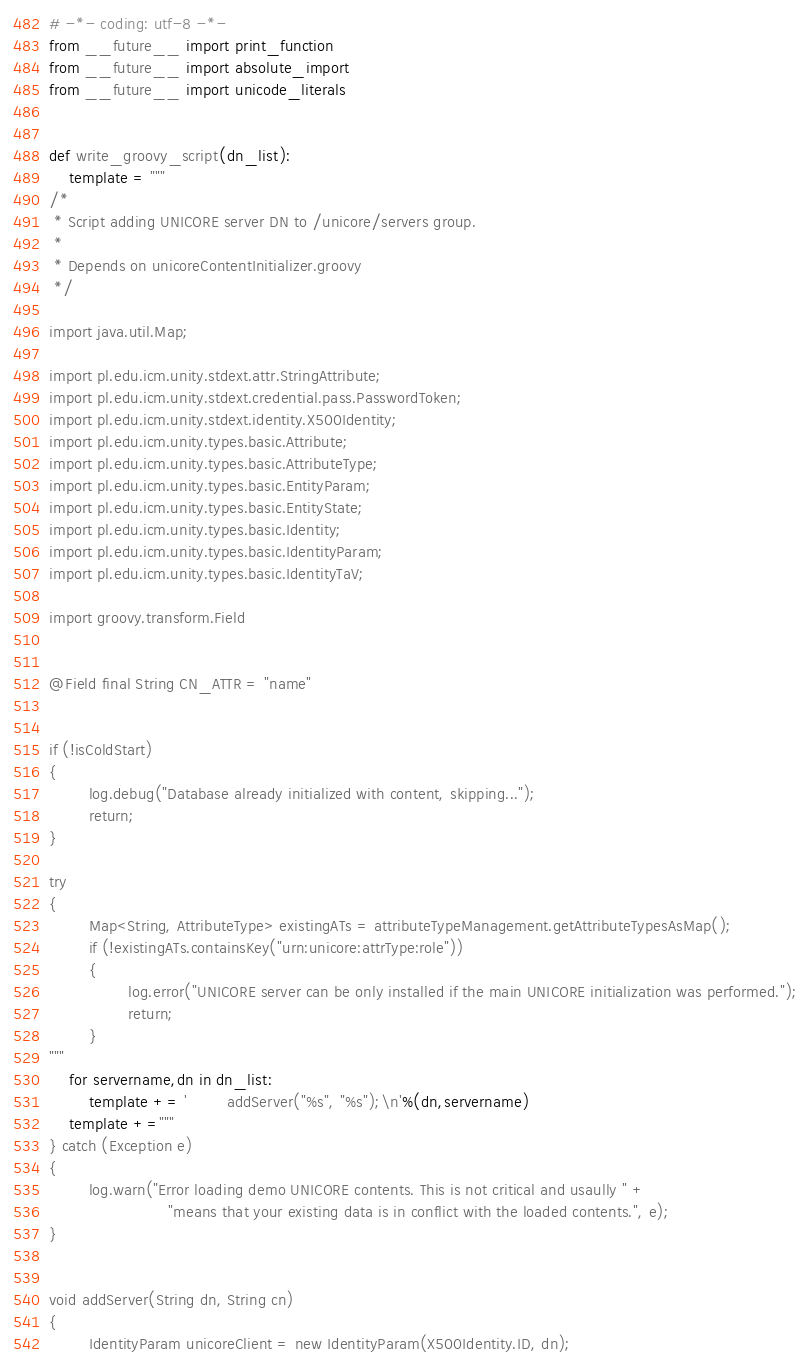Convert code to text. <code><loc_0><loc_0><loc_500><loc_500><_Python_># -*- coding: utf-8 -*-
from __future__ import print_function
from __future__ import absolute_import
from __future__ import unicode_literals


def write_groovy_script(dn_list):
    template = """
/*
 * Script adding UNICORE server DN to /unicore/servers group.  
 *
 * Depends on unicoreContentInitializer.groovy
 */

import java.util.Map;

import pl.edu.icm.unity.stdext.attr.StringAttribute;
import pl.edu.icm.unity.stdext.credential.pass.PasswordToken;
import pl.edu.icm.unity.stdext.identity.X500Identity;
import pl.edu.icm.unity.types.basic.Attribute;
import pl.edu.icm.unity.types.basic.AttributeType;
import pl.edu.icm.unity.types.basic.EntityParam;
import pl.edu.icm.unity.types.basic.EntityState;
import pl.edu.icm.unity.types.basic.Identity;
import pl.edu.icm.unity.types.basic.IdentityParam;
import pl.edu.icm.unity.types.basic.IdentityTaV;

import groovy.transform.Field


@Field final String CN_ATTR = "name"


if (!isColdStart)
{
        log.debug("Database already initialized with content, skipping...");
        return;
}

try
{
        Map<String, AttributeType> existingATs = attributeTypeManagement.getAttributeTypesAsMap();
        if (!existingATs.containsKey("urn:unicore:attrType:role"))
        {
                log.error("UNICORE server can be only installed if the main UNICORE initialization was performed.");
                return;
        }
"""
    for servername,dn in dn_list:
        template += '        addServer("%s", "%s");\n'%(dn,servername)
    template +="""
} catch (Exception e)
{
        log.warn("Error loading demo UNICORE contents. This is not critical and usaully " +
                        "means that your existing data is in conflict with the loaded contents.", e);
}


void addServer(String dn, String cn)
{
        IdentityParam unicoreClient = new IdentityParam(X500Identity.ID, dn);</code> 